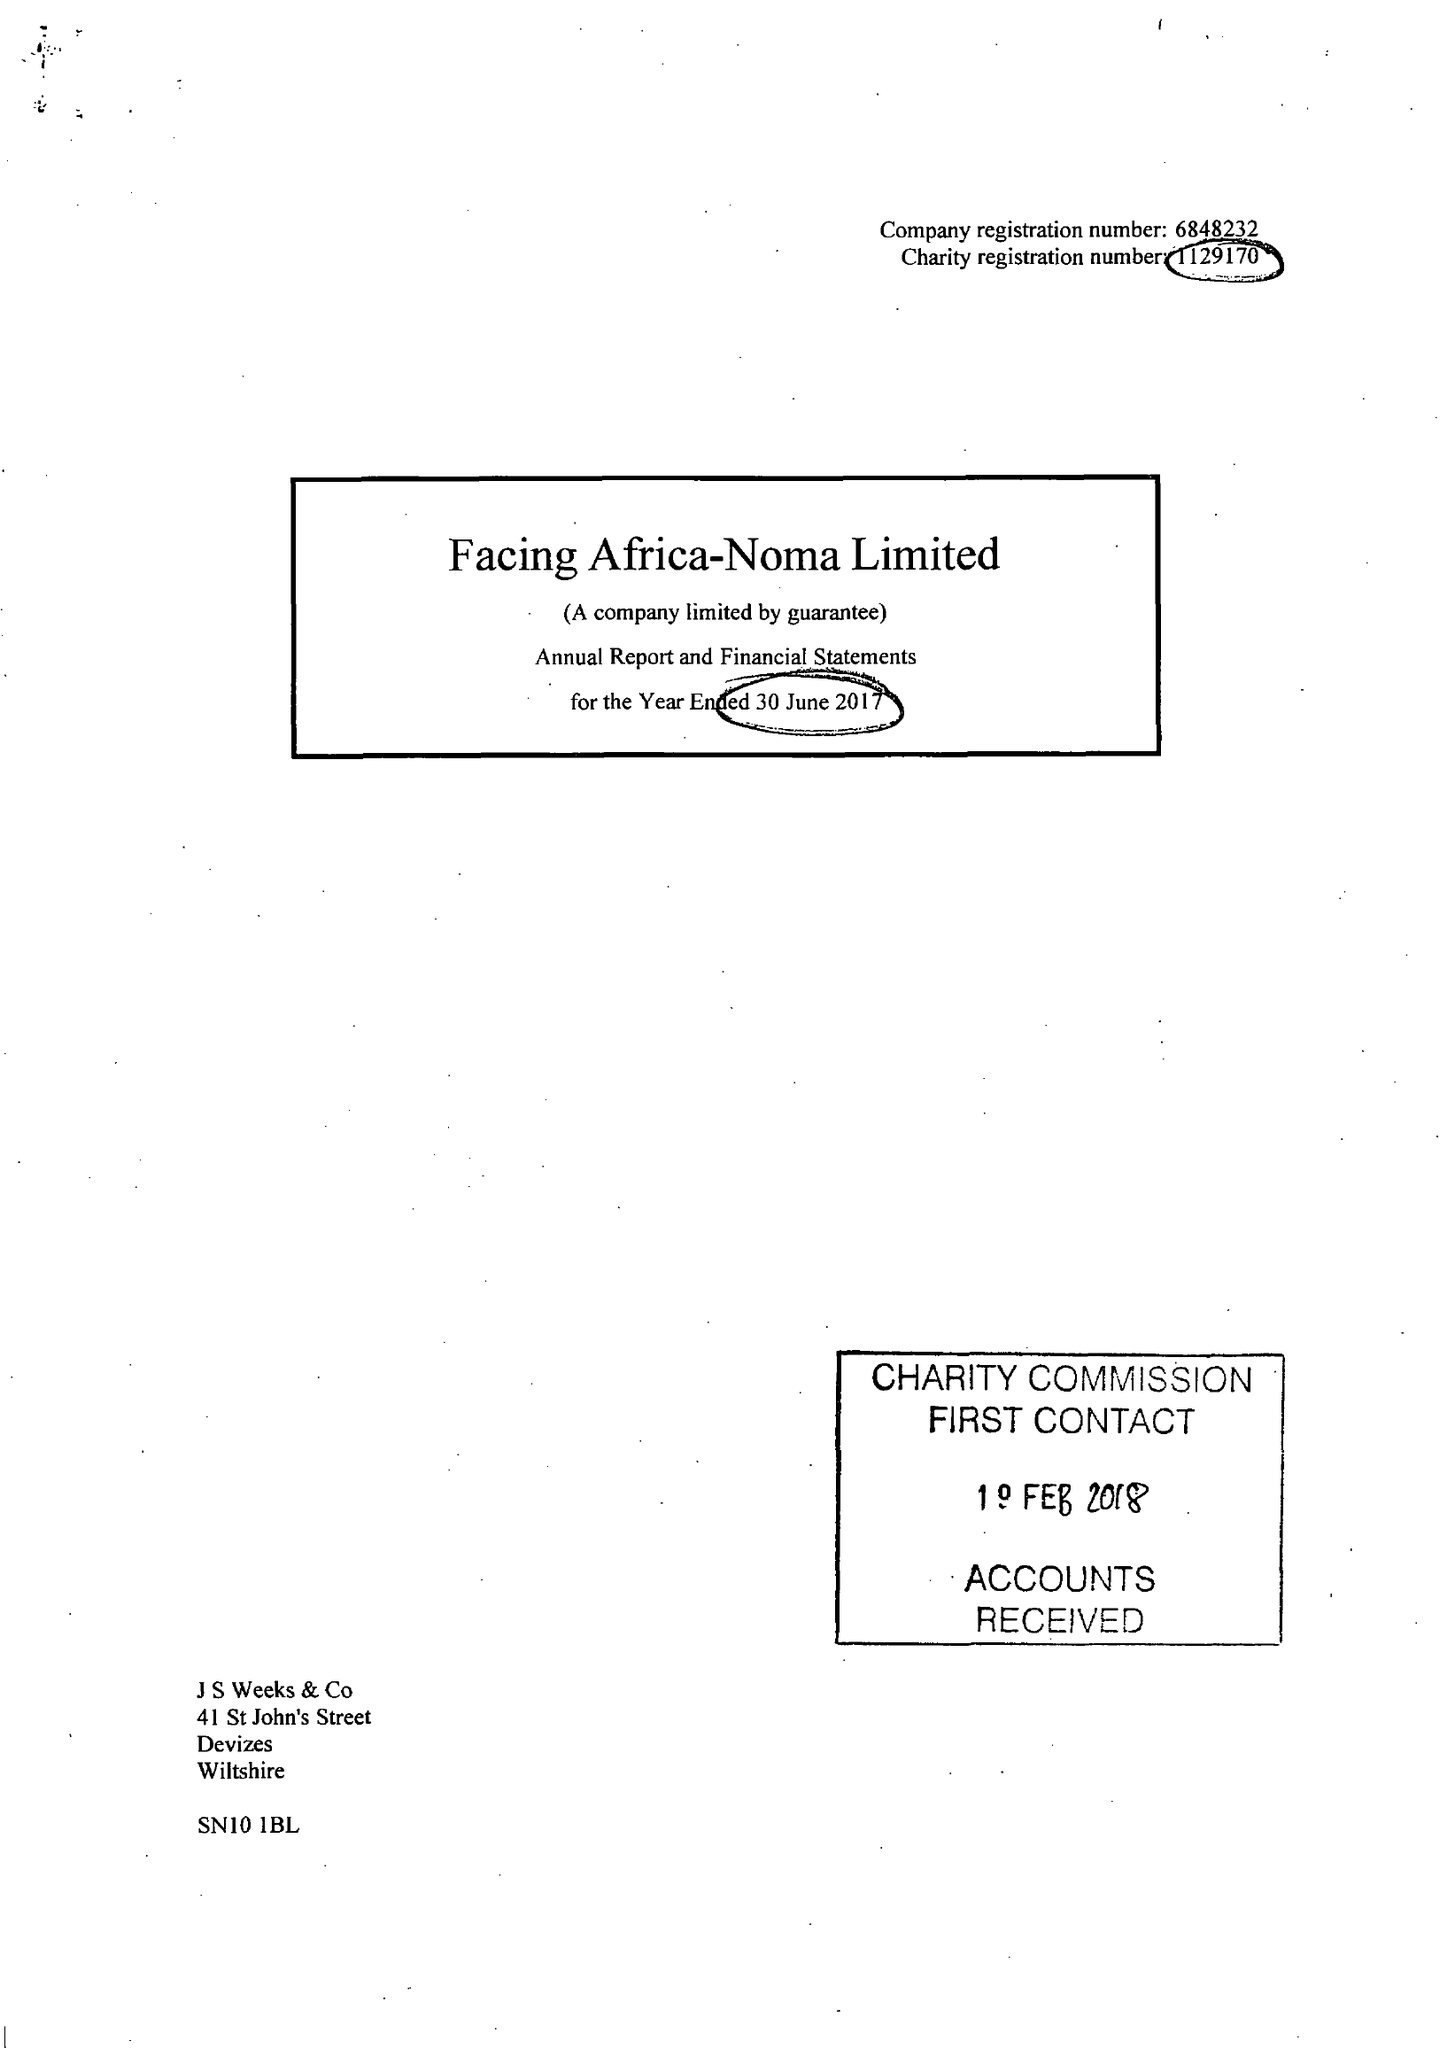What is the value for the spending_annually_in_british_pounds?
Answer the question using a single word or phrase. 280917.00 